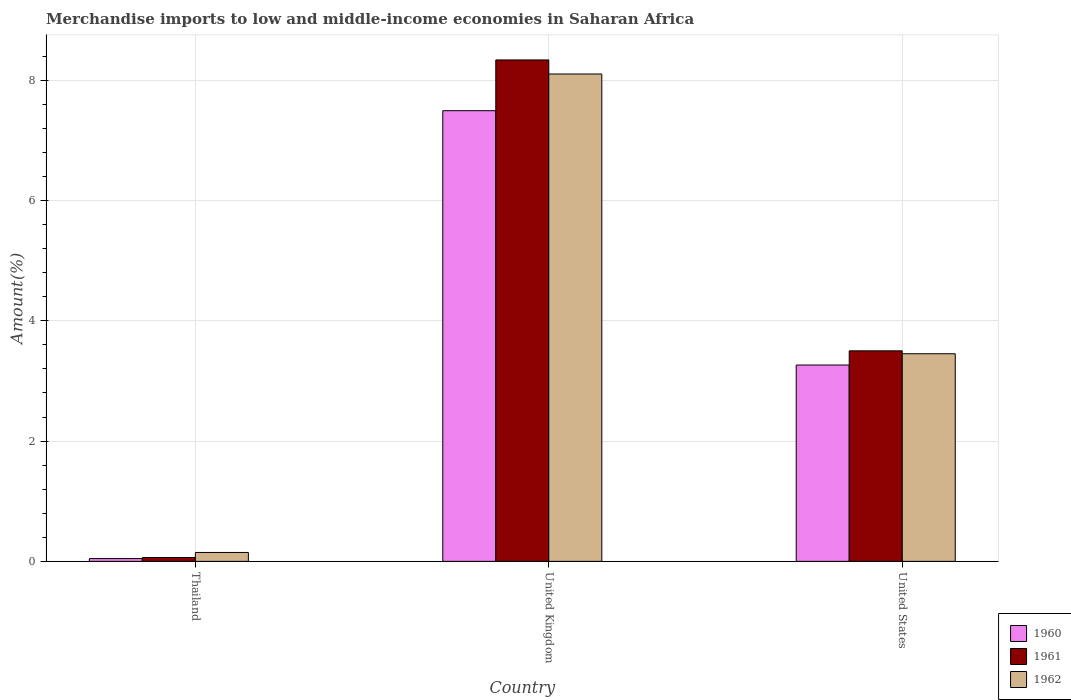How many different coloured bars are there?
Ensure brevity in your answer.  3. How many groups of bars are there?
Ensure brevity in your answer.  3. Are the number of bars per tick equal to the number of legend labels?
Provide a succinct answer. Yes. Are the number of bars on each tick of the X-axis equal?
Ensure brevity in your answer.  Yes. How many bars are there on the 1st tick from the left?
Your answer should be compact. 3. How many bars are there on the 2nd tick from the right?
Offer a terse response. 3. What is the percentage of amount earned from merchandise imports in 1961 in United States?
Offer a terse response. 3.5. Across all countries, what is the maximum percentage of amount earned from merchandise imports in 1961?
Offer a very short reply. 8.34. Across all countries, what is the minimum percentage of amount earned from merchandise imports in 1960?
Give a very brief answer. 0.05. In which country was the percentage of amount earned from merchandise imports in 1962 minimum?
Your answer should be very brief. Thailand. What is the total percentage of amount earned from merchandise imports in 1962 in the graph?
Ensure brevity in your answer.  11.71. What is the difference between the percentage of amount earned from merchandise imports in 1962 in Thailand and that in United States?
Your answer should be very brief. -3.3. What is the difference between the percentage of amount earned from merchandise imports in 1960 in United States and the percentage of amount earned from merchandise imports in 1962 in United Kingdom?
Make the answer very short. -4.84. What is the average percentage of amount earned from merchandise imports in 1960 per country?
Your answer should be compact. 3.6. What is the difference between the percentage of amount earned from merchandise imports of/in 1960 and percentage of amount earned from merchandise imports of/in 1961 in Thailand?
Provide a short and direct response. -0.02. What is the ratio of the percentage of amount earned from merchandise imports in 1960 in Thailand to that in United Kingdom?
Ensure brevity in your answer.  0.01. Is the percentage of amount earned from merchandise imports in 1961 in Thailand less than that in United States?
Keep it short and to the point. Yes. What is the difference between the highest and the second highest percentage of amount earned from merchandise imports in 1961?
Your response must be concise. 4.84. What is the difference between the highest and the lowest percentage of amount earned from merchandise imports in 1961?
Make the answer very short. 8.27. Is it the case that in every country, the sum of the percentage of amount earned from merchandise imports in 1961 and percentage of amount earned from merchandise imports in 1960 is greater than the percentage of amount earned from merchandise imports in 1962?
Ensure brevity in your answer.  No. How many bars are there?
Keep it short and to the point. 9. What is the difference between two consecutive major ticks on the Y-axis?
Provide a short and direct response. 2. Does the graph contain any zero values?
Your answer should be very brief. No. Does the graph contain grids?
Your answer should be very brief. Yes. How many legend labels are there?
Offer a very short reply. 3. How are the legend labels stacked?
Give a very brief answer. Vertical. What is the title of the graph?
Give a very brief answer. Merchandise imports to low and middle-income economies in Saharan Africa. What is the label or title of the Y-axis?
Your answer should be very brief. Amount(%). What is the Amount(%) of 1960 in Thailand?
Make the answer very short. 0.05. What is the Amount(%) in 1961 in Thailand?
Your answer should be compact. 0.06. What is the Amount(%) in 1962 in Thailand?
Your answer should be compact. 0.15. What is the Amount(%) in 1960 in United Kingdom?
Ensure brevity in your answer.  7.49. What is the Amount(%) of 1961 in United Kingdom?
Ensure brevity in your answer.  8.34. What is the Amount(%) of 1962 in United Kingdom?
Keep it short and to the point. 8.1. What is the Amount(%) of 1960 in United States?
Give a very brief answer. 3.27. What is the Amount(%) of 1961 in United States?
Provide a short and direct response. 3.5. What is the Amount(%) of 1962 in United States?
Provide a succinct answer. 3.45. Across all countries, what is the maximum Amount(%) in 1960?
Ensure brevity in your answer.  7.49. Across all countries, what is the maximum Amount(%) of 1961?
Your answer should be compact. 8.34. Across all countries, what is the maximum Amount(%) in 1962?
Ensure brevity in your answer.  8.1. Across all countries, what is the minimum Amount(%) of 1960?
Offer a very short reply. 0.05. Across all countries, what is the minimum Amount(%) in 1961?
Give a very brief answer. 0.06. Across all countries, what is the minimum Amount(%) of 1962?
Make the answer very short. 0.15. What is the total Amount(%) in 1960 in the graph?
Offer a terse response. 10.81. What is the total Amount(%) in 1961 in the graph?
Give a very brief answer. 11.9. What is the total Amount(%) in 1962 in the graph?
Your response must be concise. 11.71. What is the difference between the Amount(%) of 1960 in Thailand and that in United Kingdom?
Your answer should be compact. -7.45. What is the difference between the Amount(%) in 1961 in Thailand and that in United Kingdom?
Offer a very short reply. -8.27. What is the difference between the Amount(%) of 1962 in Thailand and that in United Kingdom?
Keep it short and to the point. -7.96. What is the difference between the Amount(%) in 1960 in Thailand and that in United States?
Make the answer very short. -3.22. What is the difference between the Amount(%) of 1961 in Thailand and that in United States?
Give a very brief answer. -3.44. What is the difference between the Amount(%) in 1962 in Thailand and that in United States?
Offer a very short reply. -3.3. What is the difference between the Amount(%) in 1960 in United Kingdom and that in United States?
Your answer should be very brief. 4.23. What is the difference between the Amount(%) of 1961 in United Kingdom and that in United States?
Provide a succinct answer. 4.84. What is the difference between the Amount(%) in 1962 in United Kingdom and that in United States?
Keep it short and to the point. 4.65. What is the difference between the Amount(%) in 1960 in Thailand and the Amount(%) in 1961 in United Kingdom?
Offer a terse response. -8.29. What is the difference between the Amount(%) in 1960 in Thailand and the Amount(%) in 1962 in United Kingdom?
Provide a succinct answer. -8.06. What is the difference between the Amount(%) in 1961 in Thailand and the Amount(%) in 1962 in United Kingdom?
Give a very brief answer. -8.04. What is the difference between the Amount(%) in 1960 in Thailand and the Amount(%) in 1961 in United States?
Keep it short and to the point. -3.45. What is the difference between the Amount(%) of 1960 in Thailand and the Amount(%) of 1962 in United States?
Provide a succinct answer. -3.41. What is the difference between the Amount(%) of 1961 in Thailand and the Amount(%) of 1962 in United States?
Your response must be concise. -3.39. What is the difference between the Amount(%) of 1960 in United Kingdom and the Amount(%) of 1961 in United States?
Your answer should be compact. 3.99. What is the difference between the Amount(%) of 1960 in United Kingdom and the Amount(%) of 1962 in United States?
Your response must be concise. 4.04. What is the difference between the Amount(%) in 1961 in United Kingdom and the Amount(%) in 1962 in United States?
Keep it short and to the point. 4.89. What is the average Amount(%) in 1960 per country?
Your response must be concise. 3.6. What is the average Amount(%) in 1961 per country?
Provide a short and direct response. 3.97. What is the average Amount(%) of 1962 per country?
Your response must be concise. 3.9. What is the difference between the Amount(%) of 1960 and Amount(%) of 1961 in Thailand?
Keep it short and to the point. -0.02. What is the difference between the Amount(%) in 1960 and Amount(%) in 1962 in Thailand?
Your answer should be compact. -0.1. What is the difference between the Amount(%) of 1961 and Amount(%) of 1962 in Thailand?
Provide a short and direct response. -0.08. What is the difference between the Amount(%) of 1960 and Amount(%) of 1961 in United Kingdom?
Keep it short and to the point. -0.84. What is the difference between the Amount(%) of 1960 and Amount(%) of 1962 in United Kingdom?
Offer a terse response. -0.61. What is the difference between the Amount(%) in 1961 and Amount(%) in 1962 in United Kingdom?
Offer a very short reply. 0.23. What is the difference between the Amount(%) of 1960 and Amount(%) of 1961 in United States?
Make the answer very short. -0.24. What is the difference between the Amount(%) of 1960 and Amount(%) of 1962 in United States?
Offer a terse response. -0.19. What is the difference between the Amount(%) of 1961 and Amount(%) of 1962 in United States?
Offer a terse response. 0.05. What is the ratio of the Amount(%) of 1960 in Thailand to that in United Kingdom?
Give a very brief answer. 0.01. What is the ratio of the Amount(%) of 1961 in Thailand to that in United Kingdom?
Give a very brief answer. 0.01. What is the ratio of the Amount(%) of 1962 in Thailand to that in United Kingdom?
Your response must be concise. 0.02. What is the ratio of the Amount(%) in 1960 in Thailand to that in United States?
Make the answer very short. 0.01. What is the ratio of the Amount(%) in 1961 in Thailand to that in United States?
Make the answer very short. 0.02. What is the ratio of the Amount(%) in 1962 in Thailand to that in United States?
Give a very brief answer. 0.04. What is the ratio of the Amount(%) in 1960 in United Kingdom to that in United States?
Offer a very short reply. 2.3. What is the ratio of the Amount(%) in 1961 in United Kingdom to that in United States?
Give a very brief answer. 2.38. What is the ratio of the Amount(%) of 1962 in United Kingdom to that in United States?
Your answer should be compact. 2.35. What is the difference between the highest and the second highest Amount(%) of 1960?
Make the answer very short. 4.23. What is the difference between the highest and the second highest Amount(%) in 1961?
Ensure brevity in your answer.  4.84. What is the difference between the highest and the second highest Amount(%) of 1962?
Provide a succinct answer. 4.65. What is the difference between the highest and the lowest Amount(%) in 1960?
Keep it short and to the point. 7.45. What is the difference between the highest and the lowest Amount(%) of 1961?
Your response must be concise. 8.27. What is the difference between the highest and the lowest Amount(%) in 1962?
Make the answer very short. 7.96. 